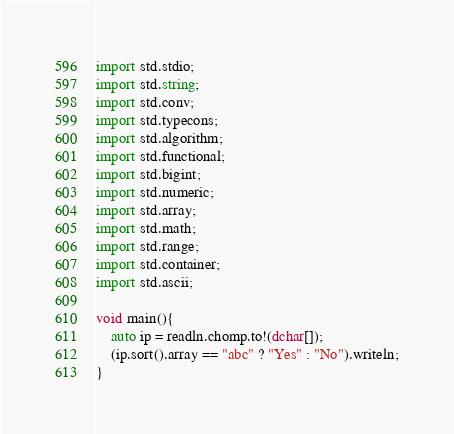Convert code to text. <code><loc_0><loc_0><loc_500><loc_500><_D_>import std.stdio;
import std.string;
import std.conv;
import std.typecons;
import std.algorithm;
import std.functional;
import std.bigint;
import std.numeric;
import std.array;
import std.math;
import std.range;
import std.container;
import std.ascii;

void main(){
	auto ip = readln.chomp.to!(dchar[]);
	(ip.sort().array == "abc" ? "Yes" : "No").writeln;
}</code> 